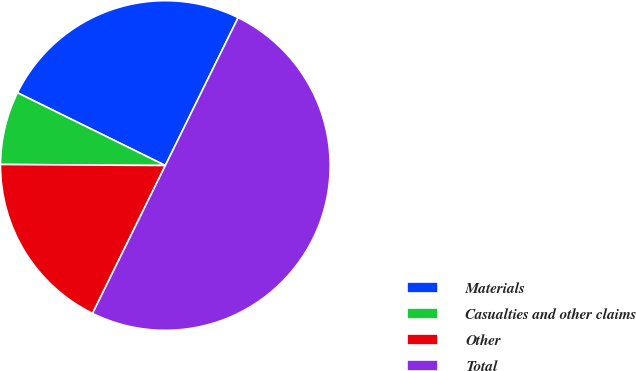Convert chart to OTSL. <chart><loc_0><loc_0><loc_500><loc_500><pie_chart><fcel>Materials<fcel>Casualties and other claims<fcel>Other<fcel>Total<nl><fcel>25.0%<fcel>7.18%<fcel>17.82%<fcel>50.0%<nl></chart> 